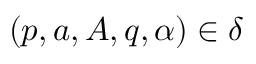<formula> <loc_0><loc_0><loc_500><loc_500>( p , a , A , q , \alpha ) \in \delta</formula> 